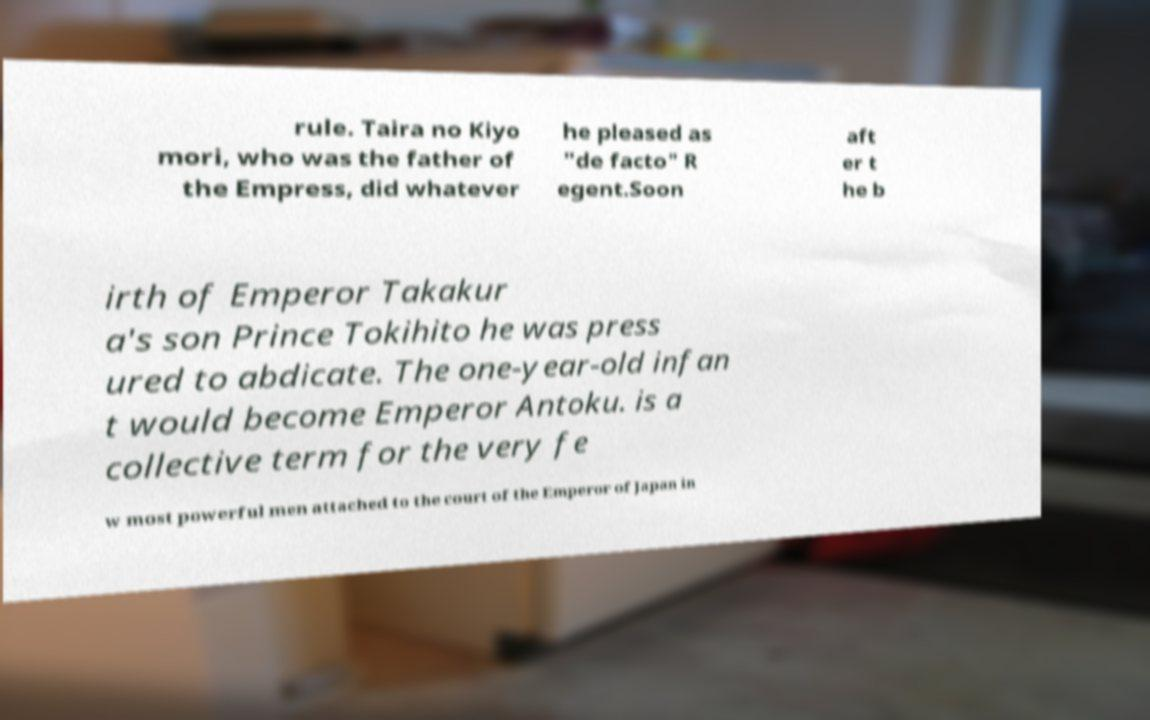Could you assist in decoding the text presented in this image and type it out clearly? rule. Taira no Kiyo mori, who was the father of the Empress, did whatever he pleased as "de facto" R egent.Soon aft er t he b irth of Emperor Takakur a's son Prince Tokihito he was press ured to abdicate. The one-year-old infan t would become Emperor Antoku. is a collective term for the very fe w most powerful men attached to the court of the Emperor of Japan in 